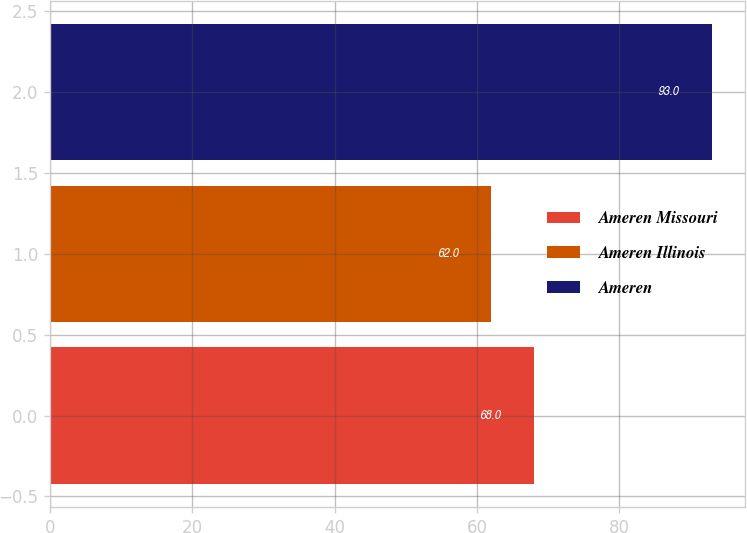Convert chart. <chart><loc_0><loc_0><loc_500><loc_500><bar_chart><fcel>Ameren Missouri<fcel>Ameren Illinois<fcel>Ameren<nl><fcel>68<fcel>62<fcel>93<nl></chart> 